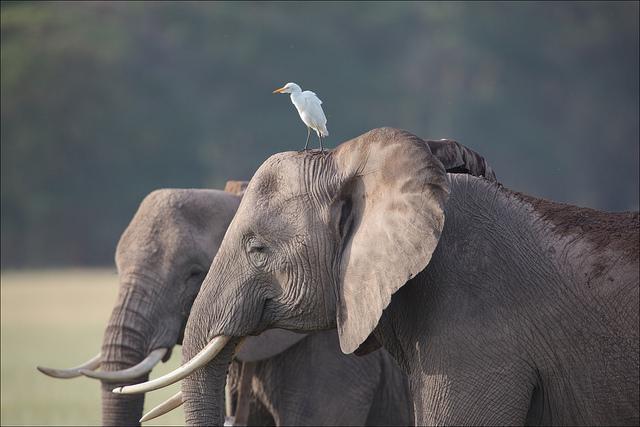How many elephants are there?
Give a very brief answer. 2. How many people are there?
Give a very brief answer. 0. 